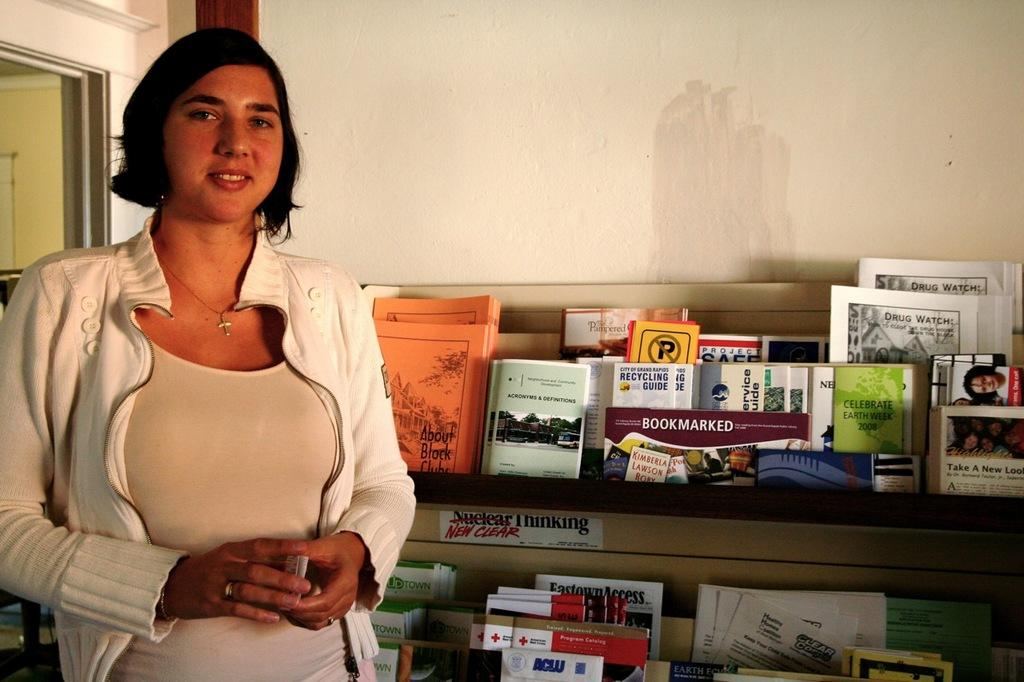What is the main subject of the image? There is a woman standing in the image. What is the woman holding in her hand? The woman is holding an object in her hand. What can be seen behind the woman? There are books in a rack behind the woman. What is the background of the books rack? There is a wall behind the books rack. What architectural feature is visible on the left side of the image? There is a door to the left of the image. How many pigs are visible in the image? There are no pigs present in the image. What type of building is shown in the image? The image does not show a building; it features a woman standing with books and a door visible. 